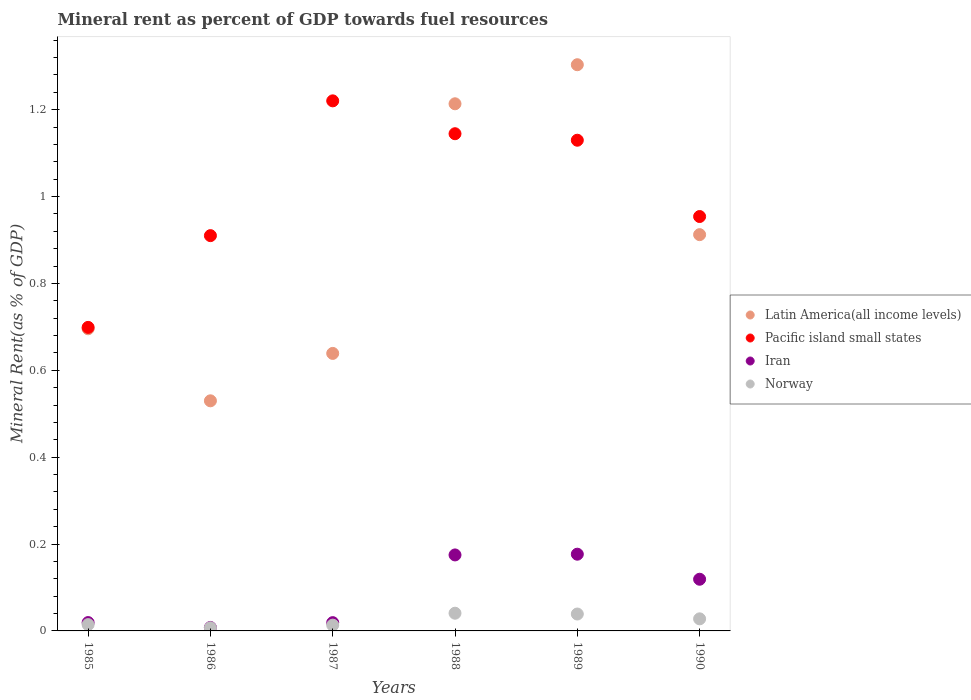How many different coloured dotlines are there?
Offer a very short reply. 4. What is the mineral rent in Latin America(all income levels) in 1988?
Make the answer very short. 1.21. Across all years, what is the maximum mineral rent in Latin America(all income levels)?
Keep it short and to the point. 1.3. Across all years, what is the minimum mineral rent in Norway?
Ensure brevity in your answer.  0.01. In which year was the mineral rent in Pacific island small states maximum?
Give a very brief answer. 1987. What is the total mineral rent in Latin America(all income levels) in the graph?
Your answer should be very brief. 5.29. What is the difference between the mineral rent in Latin America(all income levels) in 1985 and that in 1987?
Your response must be concise. 0.06. What is the difference between the mineral rent in Norway in 1988 and the mineral rent in Iran in 1986?
Your answer should be compact. 0.03. What is the average mineral rent in Iran per year?
Make the answer very short. 0.09. In the year 1989, what is the difference between the mineral rent in Iran and mineral rent in Latin America(all income levels)?
Provide a succinct answer. -1.13. In how many years, is the mineral rent in Latin America(all income levels) greater than 0.56 %?
Make the answer very short. 5. What is the ratio of the mineral rent in Norway in 1987 to that in 1990?
Make the answer very short. 0.48. What is the difference between the highest and the second highest mineral rent in Pacific island small states?
Offer a very short reply. 0.08. What is the difference between the highest and the lowest mineral rent in Norway?
Offer a terse response. 0.03. In how many years, is the mineral rent in Iran greater than the average mineral rent in Iran taken over all years?
Ensure brevity in your answer.  3. Is the sum of the mineral rent in Latin America(all income levels) in 1985 and 1990 greater than the maximum mineral rent in Pacific island small states across all years?
Give a very brief answer. Yes. Is the mineral rent in Pacific island small states strictly less than the mineral rent in Latin America(all income levels) over the years?
Your answer should be very brief. No. How many dotlines are there?
Provide a short and direct response. 4. How many years are there in the graph?
Give a very brief answer. 6. Does the graph contain grids?
Your answer should be very brief. No. How many legend labels are there?
Offer a terse response. 4. How are the legend labels stacked?
Provide a short and direct response. Vertical. What is the title of the graph?
Ensure brevity in your answer.  Mineral rent as percent of GDP towards fuel resources. Does "Algeria" appear as one of the legend labels in the graph?
Your answer should be very brief. No. What is the label or title of the X-axis?
Ensure brevity in your answer.  Years. What is the label or title of the Y-axis?
Offer a very short reply. Mineral Rent(as % of GDP). What is the Mineral Rent(as % of GDP) in Latin America(all income levels) in 1985?
Provide a short and direct response. 0.7. What is the Mineral Rent(as % of GDP) in Pacific island small states in 1985?
Ensure brevity in your answer.  0.7. What is the Mineral Rent(as % of GDP) of Iran in 1985?
Give a very brief answer. 0.02. What is the Mineral Rent(as % of GDP) in Norway in 1985?
Your response must be concise. 0.01. What is the Mineral Rent(as % of GDP) in Latin America(all income levels) in 1986?
Keep it short and to the point. 0.53. What is the Mineral Rent(as % of GDP) of Pacific island small states in 1986?
Keep it short and to the point. 0.91. What is the Mineral Rent(as % of GDP) of Iran in 1986?
Your answer should be very brief. 0.01. What is the Mineral Rent(as % of GDP) in Norway in 1986?
Provide a succinct answer. 0.01. What is the Mineral Rent(as % of GDP) of Latin America(all income levels) in 1987?
Your answer should be compact. 0.64. What is the Mineral Rent(as % of GDP) of Pacific island small states in 1987?
Give a very brief answer. 1.22. What is the Mineral Rent(as % of GDP) in Iran in 1987?
Provide a succinct answer. 0.02. What is the Mineral Rent(as % of GDP) of Norway in 1987?
Your answer should be very brief. 0.01. What is the Mineral Rent(as % of GDP) in Latin America(all income levels) in 1988?
Your answer should be very brief. 1.21. What is the Mineral Rent(as % of GDP) of Pacific island small states in 1988?
Your answer should be very brief. 1.14. What is the Mineral Rent(as % of GDP) in Iran in 1988?
Keep it short and to the point. 0.17. What is the Mineral Rent(as % of GDP) in Norway in 1988?
Your response must be concise. 0.04. What is the Mineral Rent(as % of GDP) in Latin America(all income levels) in 1989?
Provide a succinct answer. 1.3. What is the Mineral Rent(as % of GDP) of Pacific island small states in 1989?
Your answer should be very brief. 1.13. What is the Mineral Rent(as % of GDP) of Iran in 1989?
Your answer should be very brief. 0.18. What is the Mineral Rent(as % of GDP) of Norway in 1989?
Provide a short and direct response. 0.04. What is the Mineral Rent(as % of GDP) of Latin America(all income levels) in 1990?
Keep it short and to the point. 0.91. What is the Mineral Rent(as % of GDP) of Pacific island small states in 1990?
Offer a terse response. 0.95. What is the Mineral Rent(as % of GDP) of Iran in 1990?
Provide a short and direct response. 0.12. What is the Mineral Rent(as % of GDP) of Norway in 1990?
Your response must be concise. 0.03. Across all years, what is the maximum Mineral Rent(as % of GDP) of Latin America(all income levels)?
Provide a succinct answer. 1.3. Across all years, what is the maximum Mineral Rent(as % of GDP) of Pacific island small states?
Provide a short and direct response. 1.22. Across all years, what is the maximum Mineral Rent(as % of GDP) of Iran?
Make the answer very short. 0.18. Across all years, what is the maximum Mineral Rent(as % of GDP) of Norway?
Ensure brevity in your answer.  0.04. Across all years, what is the minimum Mineral Rent(as % of GDP) of Latin America(all income levels)?
Offer a terse response. 0.53. Across all years, what is the minimum Mineral Rent(as % of GDP) of Pacific island small states?
Offer a very short reply. 0.7. Across all years, what is the minimum Mineral Rent(as % of GDP) in Iran?
Provide a succinct answer. 0.01. Across all years, what is the minimum Mineral Rent(as % of GDP) in Norway?
Provide a short and direct response. 0.01. What is the total Mineral Rent(as % of GDP) in Latin America(all income levels) in the graph?
Your answer should be compact. 5.29. What is the total Mineral Rent(as % of GDP) in Pacific island small states in the graph?
Keep it short and to the point. 6.06. What is the total Mineral Rent(as % of GDP) in Iran in the graph?
Offer a terse response. 0.52. What is the total Mineral Rent(as % of GDP) of Norway in the graph?
Offer a terse response. 0.14. What is the difference between the Mineral Rent(as % of GDP) in Latin America(all income levels) in 1985 and that in 1986?
Your answer should be compact. 0.17. What is the difference between the Mineral Rent(as % of GDP) in Pacific island small states in 1985 and that in 1986?
Offer a terse response. -0.21. What is the difference between the Mineral Rent(as % of GDP) of Iran in 1985 and that in 1986?
Make the answer very short. 0.01. What is the difference between the Mineral Rent(as % of GDP) of Norway in 1985 and that in 1986?
Provide a succinct answer. 0.01. What is the difference between the Mineral Rent(as % of GDP) in Latin America(all income levels) in 1985 and that in 1987?
Make the answer very short. 0.06. What is the difference between the Mineral Rent(as % of GDP) in Pacific island small states in 1985 and that in 1987?
Give a very brief answer. -0.52. What is the difference between the Mineral Rent(as % of GDP) of Norway in 1985 and that in 1987?
Make the answer very short. 0. What is the difference between the Mineral Rent(as % of GDP) of Latin America(all income levels) in 1985 and that in 1988?
Offer a very short reply. -0.52. What is the difference between the Mineral Rent(as % of GDP) in Pacific island small states in 1985 and that in 1988?
Your answer should be very brief. -0.45. What is the difference between the Mineral Rent(as % of GDP) in Iran in 1985 and that in 1988?
Provide a succinct answer. -0.16. What is the difference between the Mineral Rent(as % of GDP) in Norway in 1985 and that in 1988?
Ensure brevity in your answer.  -0.03. What is the difference between the Mineral Rent(as % of GDP) of Latin America(all income levels) in 1985 and that in 1989?
Offer a very short reply. -0.61. What is the difference between the Mineral Rent(as % of GDP) in Pacific island small states in 1985 and that in 1989?
Your response must be concise. -0.43. What is the difference between the Mineral Rent(as % of GDP) in Iran in 1985 and that in 1989?
Keep it short and to the point. -0.16. What is the difference between the Mineral Rent(as % of GDP) in Norway in 1985 and that in 1989?
Your answer should be very brief. -0.02. What is the difference between the Mineral Rent(as % of GDP) in Latin America(all income levels) in 1985 and that in 1990?
Give a very brief answer. -0.22. What is the difference between the Mineral Rent(as % of GDP) in Pacific island small states in 1985 and that in 1990?
Give a very brief answer. -0.26. What is the difference between the Mineral Rent(as % of GDP) of Iran in 1985 and that in 1990?
Ensure brevity in your answer.  -0.1. What is the difference between the Mineral Rent(as % of GDP) in Norway in 1985 and that in 1990?
Keep it short and to the point. -0.01. What is the difference between the Mineral Rent(as % of GDP) in Latin America(all income levels) in 1986 and that in 1987?
Give a very brief answer. -0.11. What is the difference between the Mineral Rent(as % of GDP) of Pacific island small states in 1986 and that in 1987?
Give a very brief answer. -0.31. What is the difference between the Mineral Rent(as % of GDP) of Iran in 1986 and that in 1987?
Ensure brevity in your answer.  -0.01. What is the difference between the Mineral Rent(as % of GDP) of Norway in 1986 and that in 1987?
Your answer should be compact. -0.01. What is the difference between the Mineral Rent(as % of GDP) of Latin America(all income levels) in 1986 and that in 1988?
Provide a short and direct response. -0.68. What is the difference between the Mineral Rent(as % of GDP) of Pacific island small states in 1986 and that in 1988?
Offer a very short reply. -0.23. What is the difference between the Mineral Rent(as % of GDP) in Iran in 1986 and that in 1988?
Make the answer very short. -0.17. What is the difference between the Mineral Rent(as % of GDP) in Norway in 1986 and that in 1988?
Keep it short and to the point. -0.03. What is the difference between the Mineral Rent(as % of GDP) in Latin America(all income levels) in 1986 and that in 1989?
Your response must be concise. -0.77. What is the difference between the Mineral Rent(as % of GDP) of Pacific island small states in 1986 and that in 1989?
Keep it short and to the point. -0.22. What is the difference between the Mineral Rent(as % of GDP) in Iran in 1986 and that in 1989?
Ensure brevity in your answer.  -0.17. What is the difference between the Mineral Rent(as % of GDP) of Norway in 1986 and that in 1989?
Keep it short and to the point. -0.03. What is the difference between the Mineral Rent(as % of GDP) in Latin America(all income levels) in 1986 and that in 1990?
Keep it short and to the point. -0.38. What is the difference between the Mineral Rent(as % of GDP) of Pacific island small states in 1986 and that in 1990?
Provide a short and direct response. -0.04. What is the difference between the Mineral Rent(as % of GDP) in Iran in 1986 and that in 1990?
Make the answer very short. -0.11. What is the difference between the Mineral Rent(as % of GDP) in Norway in 1986 and that in 1990?
Your response must be concise. -0.02. What is the difference between the Mineral Rent(as % of GDP) of Latin America(all income levels) in 1987 and that in 1988?
Provide a short and direct response. -0.57. What is the difference between the Mineral Rent(as % of GDP) in Pacific island small states in 1987 and that in 1988?
Offer a terse response. 0.08. What is the difference between the Mineral Rent(as % of GDP) of Iran in 1987 and that in 1988?
Your answer should be compact. -0.16. What is the difference between the Mineral Rent(as % of GDP) in Norway in 1987 and that in 1988?
Ensure brevity in your answer.  -0.03. What is the difference between the Mineral Rent(as % of GDP) of Latin America(all income levels) in 1987 and that in 1989?
Offer a terse response. -0.66. What is the difference between the Mineral Rent(as % of GDP) in Pacific island small states in 1987 and that in 1989?
Provide a succinct answer. 0.09. What is the difference between the Mineral Rent(as % of GDP) in Iran in 1987 and that in 1989?
Provide a short and direct response. -0.16. What is the difference between the Mineral Rent(as % of GDP) of Norway in 1987 and that in 1989?
Your answer should be compact. -0.03. What is the difference between the Mineral Rent(as % of GDP) of Latin America(all income levels) in 1987 and that in 1990?
Keep it short and to the point. -0.27. What is the difference between the Mineral Rent(as % of GDP) of Pacific island small states in 1987 and that in 1990?
Ensure brevity in your answer.  0.27. What is the difference between the Mineral Rent(as % of GDP) of Iran in 1987 and that in 1990?
Ensure brevity in your answer.  -0.1. What is the difference between the Mineral Rent(as % of GDP) of Norway in 1987 and that in 1990?
Keep it short and to the point. -0.01. What is the difference between the Mineral Rent(as % of GDP) in Latin America(all income levels) in 1988 and that in 1989?
Offer a very short reply. -0.09. What is the difference between the Mineral Rent(as % of GDP) of Pacific island small states in 1988 and that in 1989?
Your response must be concise. 0.01. What is the difference between the Mineral Rent(as % of GDP) of Iran in 1988 and that in 1989?
Make the answer very short. -0. What is the difference between the Mineral Rent(as % of GDP) of Norway in 1988 and that in 1989?
Provide a succinct answer. 0. What is the difference between the Mineral Rent(as % of GDP) in Latin America(all income levels) in 1988 and that in 1990?
Ensure brevity in your answer.  0.3. What is the difference between the Mineral Rent(as % of GDP) of Pacific island small states in 1988 and that in 1990?
Make the answer very short. 0.19. What is the difference between the Mineral Rent(as % of GDP) in Iran in 1988 and that in 1990?
Offer a terse response. 0.06. What is the difference between the Mineral Rent(as % of GDP) in Norway in 1988 and that in 1990?
Your answer should be very brief. 0.01. What is the difference between the Mineral Rent(as % of GDP) in Latin America(all income levels) in 1989 and that in 1990?
Keep it short and to the point. 0.39. What is the difference between the Mineral Rent(as % of GDP) of Pacific island small states in 1989 and that in 1990?
Offer a terse response. 0.18. What is the difference between the Mineral Rent(as % of GDP) of Iran in 1989 and that in 1990?
Keep it short and to the point. 0.06. What is the difference between the Mineral Rent(as % of GDP) of Norway in 1989 and that in 1990?
Offer a terse response. 0.01. What is the difference between the Mineral Rent(as % of GDP) of Latin America(all income levels) in 1985 and the Mineral Rent(as % of GDP) of Pacific island small states in 1986?
Make the answer very short. -0.21. What is the difference between the Mineral Rent(as % of GDP) in Latin America(all income levels) in 1985 and the Mineral Rent(as % of GDP) in Iran in 1986?
Your answer should be compact. 0.69. What is the difference between the Mineral Rent(as % of GDP) in Latin America(all income levels) in 1985 and the Mineral Rent(as % of GDP) in Norway in 1986?
Provide a succinct answer. 0.69. What is the difference between the Mineral Rent(as % of GDP) in Pacific island small states in 1985 and the Mineral Rent(as % of GDP) in Iran in 1986?
Your answer should be compact. 0.69. What is the difference between the Mineral Rent(as % of GDP) of Pacific island small states in 1985 and the Mineral Rent(as % of GDP) of Norway in 1986?
Your answer should be compact. 0.69. What is the difference between the Mineral Rent(as % of GDP) of Iran in 1985 and the Mineral Rent(as % of GDP) of Norway in 1986?
Provide a succinct answer. 0.01. What is the difference between the Mineral Rent(as % of GDP) of Latin America(all income levels) in 1985 and the Mineral Rent(as % of GDP) of Pacific island small states in 1987?
Ensure brevity in your answer.  -0.52. What is the difference between the Mineral Rent(as % of GDP) of Latin America(all income levels) in 1985 and the Mineral Rent(as % of GDP) of Iran in 1987?
Give a very brief answer. 0.68. What is the difference between the Mineral Rent(as % of GDP) in Latin America(all income levels) in 1985 and the Mineral Rent(as % of GDP) in Norway in 1987?
Ensure brevity in your answer.  0.68. What is the difference between the Mineral Rent(as % of GDP) in Pacific island small states in 1985 and the Mineral Rent(as % of GDP) in Iran in 1987?
Ensure brevity in your answer.  0.68. What is the difference between the Mineral Rent(as % of GDP) in Pacific island small states in 1985 and the Mineral Rent(as % of GDP) in Norway in 1987?
Provide a succinct answer. 0.69. What is the difference between the Mineral Rent(as % of GDP) in Iran in 1985 and the Mineral Rent(as % of GDP) in Norway in 1987?
Provide a short and direct response. 0.01. What is the difference between the Mineral Rent(as % of GDP) of Latin America(all income levels) in 1985 and the Mineral Rent(as % of GDP) of Pacific island small states in 1988?
Your response must be concise. -0.45. What is the difference between the Mineral Rent(as % of GDP) of Latin America(all income levels) in 1985 and the Mineral Rent(as % of GDP) of Iran in 1988?
Provide a short and direct response. 0.52. What is the difference between the Mineral Rent(as % of GDP) of Latin America(all income levels) in 1985 and the Mineral Rent(as % of GDP) of Norway in 1988?
Make the answer very short. 0.65. What is the difference between the Mineral Rent(as % of GDP) of Pacific island small states in 1985 and the Mineral Rent(as % of GDP) of Iran in 1988?
Provide a succinct answer. 0.52. What is the difference between the Mineral Rent(as % of GDP) in Pacific island small states in 1985 and the Mineral Rent(as % of GDP) in Norway in 1988?
Keep it short and to the point. 0.66. What is the difference between the Mineral Rent(as % of GDP) of Iran in 1985 and the Mineral Rent(as % of GDP) of Norway in 1988?
Offer a very short reply. -0.02. What is the difference between the Mineral Rent(as % of GDP) in Latin America(all income levels) in 1985 and the Mineral Rent(as % of GDP) in Pacific island small states in 1989?
Provide a short and direct response. -0.43. What is the difference between the Mineral Rent(as % of GDP) in Latin America(all income levels) in 1985 and the Mineral Rent(as % of GDP) in Iran in 1989?
Make the answer very short. 0.52. What is the difference between the Mineral Rent(as % of GDP) in Latin America(all income levels) in 1985 and the Mineral Rent(as % of GDP) in Norway in 1989?
Offer a terse response. 0.66. What is the difference between the Mineral Rent(as % of GDP) in Pacific island small states in 1985 and the Mineral Rent(as % of GDP) in Iran in 1989?
Ensure brevity in your answer.  0.52. What is the difference between the Mineral Rent(as % of GDP) of Pacific island small states in 1985 and the Mineral Rent(as % of GDP) of Norway in 1989?
Provide a short and direct response. 0.66. What is the difference between the Mineral Rent(as % of GDP) in Iran in 1985 and the Mineral Rent(as % of GDP) in Norway in 1989?
Make the answer very short. -0.02. What is the difference between the Mineral Rent(as % of GDP) in Latin America(all income levels) in 1985 and the Mineral Rent(as % of GDP) in Pacific island small states in 1990?
Ensure brevity in your answer.  -0.26. What is the difference between the Mineral Rent(as % of GDP) in Latin America(all income levels) in 1985 and the Mineral Rent(as % of GDP) in Iran in 1990?
Offer a terse response. 0.58. What is the difference between the Mineral Rent(as % of GDP) in Latin America(all income levels) in 1985 and the Mineral Rent(as % of GDP) in Norway in 1990?
Your answer should be very brief. 0.67. What is the difference between the Mineral Rent(as % of GDP) in Pacific island small states in 1985 and the Mineral Rent(as % of GDP) in Iran in 1990?
Offer a very short reply. 0.58. What is the difference between the Mineral Rent(as % of GDP) of Pacific island small states in 1985 and the Mineral Rent(as % of GDP) of Norway in 1990?
Offer a very short reply. 0.67. What is the difference between the Mineral Rent(as % of GDP) in Iran in 1985 and the Mineral Rent(as % of GDP) in Norway in 1990?
Your answer should be compact. -0.01. What is the difference between the Mineral Rent(as % of GDP) in Latin America(all income levels) in 1986 and the Mineral Rent(as % of GDP) in Pacific island small states in 1987?
Offer a terse response. -0.69. What is the difference between the Mineral Rent(as % of GDP) in Latin America(all income levels) in 1986 and the Mineral Rent(as % of GDP) in Iran in 1987?
Keep it short and to the point. 0.51. What is the difference between the Mineral Rent(as % of GDP) of Latin America(all income levels) in 1986 and the Mineral Rent(as % of GDP) of Norway in 1987?
Give a very brief answer. 0.52. What is the difference between the Mineral Rent(as % of GDP) of Pacific island small states in 1986 and the Mineral Rent(as % of GDP) of Iran in 1987?
Give a very brief answer. 0.89. What is the difference between the Mineral Rent(as % of GDP) in Pacific island small states in 1986 and the Mineral Rent(as % of GDP) in Norway in 1987?
Your answer should be very brief. 0.9. What is the difference between the Mineral Rent(as % of GDP) of Iran in 1986 and the Mineral Rent(as % of GDP) of Norway in 1987?
Your answer should be very brief. -0.01. What is the difference between the Mineral Rent(as % of GDP) in Latin America(all income levels) in 1986 and the Mineral Rent(as % of GDP) in Pacific island small states in 1988?
Your response must be concise. -0.61. What is the difference between the Mineral Rent(as % of GDP) in Latin America(all income levels) in 1986 and the Mineral Rent(as % of GDP) in Iran in 1988?
Keep it short and to the point. 0.35. What is the difference between the Mineral Rent(as % of GDP) in Latin America(all income levels) in 1986 and the Mineral Rent(as % of GDP) in Norway in 1988?
Your response must be concise. 0.49. What is the difference between the Mineral Rent(as % of GDP) in Pacific island small states in 1986 and the Mineral Rent(as % of GDP) in Iran in 1988?
Your answer should be compact. 0.73. What is the difference between the Mineral Rent(as % of GDP) in Pacific island small states in 1986 and the Mineral Rent(as % of GDP) in Norway in 1988?
Keep it short and to the point. 0.87. What is the difference between the Mineral Rent(as % of GDP) in Iran in 1986 and the Mineral Rent(as % of GDP) in Norway in 1988?
Your answer should be very brief. -0.03. What is the difference between the Mineral Rent(as % of GDP) in Latin America(all income levels) in 1986 and the Mineral Rent(as % of GDP) in Pacific island small states in 1989?
Give a very brief answer. -0.6. What is the difference between the Mineral Rent(as % of GDP) of Latin America(all income levels) in 1986 and the Mineral Rent(as % of GDP) of Iran in 1989?
Offer a very short reply. 0.35. What is the difference between the Mineral Rent(as % of GDP) of Latin America(all income levels) in 1986 and the Mineral Rent(as % of GDP) of Norway in 1989?
Ensure brevity in your answer.  0.49. What is the difference between the Mineral Rent(as % of GDP) in Pacific island small states in 1986 and the Mineral Rent(as % of GDP) in Iran in 1989?
Keep it short and to the point. 0.73. What is the difference between the Mineral Rent(as % of GDP) in Pacific island small states in 1986 and the Mineral Rent(as % of GDP) in Norway in 1989?
Keep it short and to the point. 0.87. What is the difference between the Mineral Rent(as % of GDP) in Iran in 1986 and the Mineral Rent(as % of GDP) in Norway in 1989?
Provide a succinct answer. -0.03. What is the difference between the Mineral Rent(as % of GDP) of Latin America(all income levels) in 1986 and the Mineral Rent(as % of GDP) of Pacific island small states in 1990?
Your answer should be very brief. -0.42. What is the difference between the Mineral Rent(as % of GDP) in Latin America(all income levels) in 1986 and the Mineral Rent(as % of GDP) in Iran in 1990?
Keep it short and to the point. 0.41. What is the difference between the Mineral Rent(as % of GDP) in Latin America(all income levels) in 1986 and the Mineral Rent(as % of GDP) in Norway in 1990?
Make the answer very short. 0.5. What is the difference between the Mineral Rent(as % of GDP) in Pacific island small states in 1986 and the Mineral Rent(as % of GDP) in Iran in 1990?
Give a very brief answer. 0.79. What is the difference between the Mineral Rent(as % of GDP) of Pacific island small states in 1986 and the Mineral Rent(as % of GDP) of Norway in 1990?
Ensure brevity in your answer.  0.88. What is the difference between the Mineral Rent(as % of GDP) of Iran in 1986 and the Mineral Rent(as % of GDP) of Norway in 1990?
Your response must be concise. -0.02. What is the difference between the Mineral Rent(as % of GDP) in Latin America(all income levels) in 1987 and the Mineral Rent(as % of GDP) in Pacific island small states in 1988?
Your response must be concise. -0.51. What is the difference between the Mineral Rent(as % of GDP) in Latin America(all income levels) in 1987 and the Mineral Rent(as % of GDP) in Iran in 1988?
Your answer should be compact. 0.46. What is the difference between the Mineral Rent(as % of GDP) in Latin America(all income levels) in 1987 and the Mineral Rent(as % of GDP) in Norway in 1988?
Provide a succinct answer. 0.6. What is the difference between the Mineral Rent(as % of GDP) in Pacific island small states in 1987 and the Mineral Rent(as % of GDP) in Iran in 1988?
Your answer should be very brief. 1.05. What is the difference between the Mineral Rent(as % of GDP) in Pacific island small states in 1987 and the Mineral Rent(as % of GDP) in Norway in 1988?
Provide a succinct answer. 1.18. What is the difference between the Mineral Rent(as % of GDP) of Iran in 1987 and the Mineral Rent(as % of GDP) of Norway in 1988?
Ensure brevity in your answer.  -0.02. What is the difference between the Mineral Rent(as % of GDP) in Latin America(all income levels) in 1987 and the Mineral Rent(as % of GDP) in Pacific island small states in 1989?
Keep it short and to the point. -0.49. What is the difference between the Mineral Rent(as % of GDP) of Latin America(all income levels) in 1987 and the Mineral Rent(as % of GDP) of Iran in 1989?
Your answer should be compact. 0.46. What is the difference between the Mineral Rent(as % of GDP) in Latin America(all income levels) in 1987 and the Mineral Rent(as % of GDP) in Norway in 1989?
Provide a short and direct response. 0.6. What is the difference between the Mineral Rent(as % of GDP) in Pacific island small states in 1987 and the Mineral Rent(as % of GDP) in Iran in 1989?
Give a very brief answer. 1.04. What is the difference between the Mineral Rent(as % of GDP) in Pacific island small states in 1987 and the Mineral Rent(as % of GDP) in Norway in 1989?
Ensure brevity in your answer.  1.18. What is the difference between the Mineral Rent(as % of GDP) of Iran in 1987 and the Mineral Rent(as % of GDP) of Norway in 1989?
Offer a terse response. -0.02. What is the difference between the Mineral Rent(as % of GDP) in Latin America(all income levels) in 1987 and the Mineral Rent(as % of GDP) in Pacific island small states in 1990?
Offer a very short reply. -0.32. What is the difference between the Mineral Rent(as % of GDP) in Latin America(all income levels) in 1987 and the Mineral Rent(as % of GDP) in Iran in 1990?
Provide a succinct answer. 0.52. What is the difference between the Mineral Rent(as % of GDP) of Latin America(all income levels) in 1987 and the Mineral Rent(as % of GDP) of Norway in 1990?
Your response must be concise. 0.61. What is the difference between the Mineral Rent(as % of GDP) in Pacific island small states in 1987 and the Mineral Rent(as % of GDP) in Iran in 1990?
Give a very brief answer. 1.1. What is the difference between the Mineral Rent(as % of GDP) of Pacific island small states in 1987 and the Mineral Rent(as % of GDP) of Norway in 1990?
Give a very brief answer. 1.19. What is the difference between the Mineral Rent(as % of GDP) of Iran in 1987 and the Mineral Rent(as % of GDP) of Norway in 1990?
Give a very brief answer. -0.01. What is the difference between the Mineral Rent(as % of GDP) in Latin America(all income levels) in 1988 and the Mineral Rent(as % of GDP) in Pacific island small states in 1989?
Give a very brief answer. 0.08. What is the difference between the Mineral Rent(as % of GDP) in Latin America(all income levels) in 1988 and the Mineral Rent(as % of GDP) in Iran in 1989?
Offer a terse response. 1.04. What is the difference between the Mineral Rent(as % of GDP) of Latin America(all income levels) in 1988 and the Mineral Rent(as % of GDP) of Norway in 1989?
Ensure brevity in your answer.  1.17. What is the difference between the Mineral Rent(as % of GDP) in Pacific island small states in 1988 and the Mineral Rent(as % of GDP) in Norway in 1989?
Provide a short and direct response. 1.11. What is the difference between the Mineral Rent(as % of GDP) of Iran in 1988 and the Mineral Rent(as % of GDP) of Norway in 1989?
Offer a very short reply. 0.14. What is the difference between the Mineral Rent(as % of GDP) in Latin America(all income levels) in 1988 and the Mineral Rent(as % of GDP) in Pacific island small states in 1990?
Keep it short and to the point. 0.26. What is the difference between the Mineral Rent(as % of GDP) in Latin America(all income levels) in 1988 and the Mineral Rent(as % of GDP) in Iran in 1990?
Provide a succinct answer. 1.09. What is the difference between the Mineral Rent(as % of GDP) in Latin America(all income levels) in 1988 and the Mineral Rent(as % of GDP) in Norway in 1990?
Make the answer very short. 1.19. What is the difference between the Mineral Rent(as % of GDP) in Pacific island small states in 1988 and the Mineral Rent(as % of GDP) in Iran in 1990?
Your response must be concise. 1.03. What is the difference between the Mineral Rent(as % of GDP) in Pacific island small states in 1988 and the Mineral Rent(as % of GDP) in Norway in 1990?
Your answer should be very brief. 1.12. What is the difference between the Mineral Rent(as % of GDP) of Iran in 1988 and the Mineral Rent(as % of GDP) of Norway in 1990?
Provide a succinct answer. 0.15. What is the difference between the Mineral Rent(as % of GDP) of Latin America(all income levels) in 1989 and the Mineral Rent(as % of GDP) of Pacific island small states in 1990?
Give a very brief answer. 0.35. What is the difference between the Mineral Rent(as % of GDP) in Latin America(all income levels) in 1989 and the Mineral Rent(as % of GDP) in Iran in 1990?
Give a very brief answer. 1.18. What is the difference between the Mineral Rent(as % of GDP) of Latin America(all income levels) in 1989 and the Mineral Rent(as % of GDP) of Norway in 1990?
Make the answer very short. 1.28. What is the difference between the Mineral Rent(as % of GDP) in Pacific island small states in 1989 and the Mineral Rent(as % of GDP) in Iran in 1990?
Ensure brevity in your answer.  1.01. What is the difference between the Mineral Rent(as % of GDP) in Pacific island small states in 1989 and the Mineral Rent(as % of GDP) in Norway in 1990?
Provide a short and direct response. 1.1. What is the difference between the Mineral Rent(as % of GDP) in Iran in 1989 and the Mineral Rent(as % of GDP) in Norway in 1990?
Your answer should be compact. 0.15. What is the average Mineral Rent(as % of GDP) in Latin America(all income levels) per year?
Give a very brief answer. 0.88. What is the average Mineral Rent(as % of GDP) of Pacific island small states per year?
Your answer should be very brief. 1.01. What is the average Mineral Rent(as % of GDP) of Iran per year?
Make the answer very short. 0.09. What is the average Mineral Rent(as % of GDP) of Norway per year?
Your answer should be very brief. 0.02. In the year 1985, what is the difference between the Mineral Rent(as % of GDP) in Latin America(all income levels) and Mineral Rent(as % of GDP) in Pacific island small states?
Offer a very short reply. -0. In the year 1985, what is the difference between the Mineral Rent(as % of GDP) of Latin America(all income levels) and Mineral Rent(as % of GDP) of Iran?
Your answer should be compact. 0.68. In the year 1985, what is the difference between the Mineral Rent(as % of GDP) of Latin America(all income levels) and Mineral Rent(as % of GDP) of Norway?
Provide a short and direct response. 0.68. In the year 1985, what is the difference between the Mineral Rent(as % of GDP) in Pacific island small states and Mineral Rent(as % of GDP) in Iran?
Offer a terse response. 0.68. In the year 1985, what is the difference between the Mineral Rent(as % of GDP) of Pacific island small states and Mineral Rent(as % of GDP) of Norway?
Your response must be concise. 0.68. In the year 1985, what is the difference between the Mineral Rent(as % of GDP) of Iran and Mineral Rent(as % of GDP) of Norway?
Provide a succinct answer. 0. In the year 1986, what is the difference between the Mineral Rent(as % of GDP) in Latin America(all income levels) and Mineral Rent(as % of GDP) in Pacific island small states?
Keep it short and to the point. -0.38. In the year 1986, what is the difference between the Mineral Rent(as % of GDP) in Latin America(all income levels) and Mineral Rent(as % of GDP) in Iran?
Offer a very short reply. 0.52. In the year 1986, what is the difference between the Mineral Rent(as % of GDP) in Latin America(all income levels) and Mineral Rent(as % of GDP) in Norway?
Your answer should be very brief. 0.52. In the year 1986, what is the difference between the Mineral Rent(as % of GDP) of Pacific island small states and Mineral Rent(as % of GDP) of Iran?
Ensure brevity in your answer.  0.9. In the year 1986, what is the difference between the Mineral Rent(as % of GDP) in Pacific island small states and Mineral Rent(as % of GDP) in Norway?
Provide a succinct answer. 0.9. In the year 1986, what is the difference between the Mineral Rent(as % of GDP) in Iran and Mineral Rent(as % of GDP) in Norway?
Provide a short and direct response. 0. In the year 1987, what is the difference between the Mineral Rent(as % of GDP) in Latin America(all income levels) and Mineral Rent(as % of GDP) in Pacific island small states?
Make the answer very short. -0.58. In the year 1987, what is the difference between the Mineral Rent(as % of GDP) in Latin America(all income levels) and Mineral Rent(as % of GDP) in Iran?
Your answer should be very brief. 0.62. In the year 1987, what is the difference between the Mineral Rent(as % of GDP) of Latin America(all income levels) and Mineral Rent(as % of GDP) of Norway?
Keep it short and to the point. 0.63. In the year 1987, what is the difference between the Mineral Rent(as % of GDP) in Pacific island small states and Mineral Rent(as % of GDP) in Iran?
Your answer should be compact. 1.2. In the year 1987, what is the difference between the Mineral Rent(as % of GDP) of Pacific island small states and Mineral Rent(as % of GDP) of Norway?
Your response must be concise. 1.21. In the year 1987, what is the difference between the Mineral Rent(as % of GDP) in Iran and Mineral Rent(as % of GDP) in Norway?
Provide a short and direct response. 0.01. In the year 1988, what is the difference between the Mineral Rent(as % of GDP) of Latin America(all income levels) and Mineral Rent(as % of GDP) of Pacific island small states?
Provide a short and direct response. 0.07. In the year 1988, what is the difference between the Mineral Rent(as % of GDP) in Latin America(all income levels) and Mineral Rent(as % of GDP) in Iran?
Ensure brevity in your answer.  1.04. In the year 1988, what is the difference between the Mineral Rent(as % of GDP) of Latin America(all income levels) and Mineral Rent(as % of GDP) of Norway?
Give a very brief answer. 1.17. In the year 1988, what is the difference between the Mineral Rent(as % of GDP) in Pacific island small states and Mineral Rent(as % of GDP) in Iran?
Your answer should be compact. 0.97. In the year 1988, what is the difference between the Mineral Rent(as % of GDP) in Pacific island small states and Mineral Rent(as % of GDP) in Norway?
Your response must be concise. 1.1. In the year 1988, what is the difference between the Mineral Rent(as % of GDP) in Iran and Mineral Rent(as % of GDP) in Norway?
Offer a very short reply. 0.13. In the year 1989, what is the difference between the Mineral Rent(as % of GDP) in Latin America(all income levels) and Mineral Rent(as % of GDP) in Pacific island small states?
Provide a short and direct response. 0.17. In the year 1989, what is the difference between the Mineral Rent(as % of GDP) of Latin America(all income levels) and Mineral Rent(as % of GDP) of Iran?
Make the answer very short. 1.13. In the year 1989, what is the difference between the Mineral Rent(as % of GDP) in Latin America(all income levels) and Mineral Rent(as % of GDP) in Norway?
Make the answer very short. 1.26. In the year 1989, what is the difference between the Mineral Rent(as % of GDP) in Pacific island small states and Mineral Rent(as % of GDP) in Iran?
Make the answer very short. 0.95. In the year 1989, what is the difference between the Mineral Rent(as % of GDP) in Pacific island small states and Mineral Rent(as % of GDP) in Norway?
Your answer should be compact. 1.09. In the year 1989, what is the difference between the Mineral Rent(as % of GDP) in Iran and Mineral Rent(as % of GDP) in Norway?
Your answer should be compact. 0.14. In the year 1990, what is the difference between the Mineral Rent(as % of GDP) in Latin America(all income levels) and Mineral Rent(as % of GDP) in Pacific island small states?
Make the answer very short. -0.04. In the year 1990, what is the difference between the Mineral Rent(as % of GDP) of Latin America(all income levels) and Mineral Rent(as % of GDP) of Iran?
Provide a short and direct response. 0.79. In the year 1990, what is the difference between the Mineral Rent(as % of GDP) in Latin America(all income levels) and Mineral Rent(as % of GDP) in Norway?
Keep it short and to the point. 0.88. In the year 1990, what is the difference between the Mineral Rent(as % of GDP) in Pacific island small states and Mineral Rent(as % of GDP) in Iran?
Your answer should be very brief. 0.83. In the year 1990, what is the difference between the Mineral Rent(as % of GDP) in Pacific island small states and Mineral Rent(as % of GDP) in Norway?
Your answer should be compact. 0.93. In the year 1990, what is the difference between the Mineral Rent(as % of GDP) of Iran and Mineral Rent(as % of GDP) of Norway?
Keep it short and to the point. 0.09. What is the ratio of the Mineral Rent(as % of GDP) of Latin America(all income levels) in 1985 to that in 1986?
Keep it short and to the point. 1.31. What is the ratio of the Mineral Rent(as % of GDP) of Pacific island small states in 1985 to that in 1986?
Your answer should be compact. 0.77. What is the ratio of the Mineral Rent(as % of GDP) in Iran in 1985 to that in 1986?
Offer a terse response. 2.4. What is the ratio of the Mineral Rent(as % of GDP) of Norway in 1985 to that in 1986?
Offer a terse response. 2.01. What is the ratio of the Mineral Rent(as % of GDP) in Latin America(all income levels) in 1985 to that in 1987?
Provide a succinct answer. 1.09. What is the ratio of the Mineral Rent(as % of GDP) in Pacific island small states in 1985 to that in 1987?
Make the answer very short. 0.57. What is the ratio of the Mineral Rent(as % of GDP) in Iran in 1985 to that in 1987?
Your answer should be very brief. 1.01. What is the ratio of the Mineral Rent(as % of GDP) in Norway in 1985 to that in 1987?
Your answer should be compact. 1.09. What is the ratio of the Mineral Rent(as % of GDP) in Latin America(all income levels) in 1985 to that in 1988?
Offer a terse response. 0.57. What is the ratio of the Mineral Rent(as % of GDP) in Pacific island small states in 1985 to that in 1988?
Keep it short and to the point. 0.61. What is the ratio of the Mineral Rent(as % of GDP) of Iran in 1985 to that in 1988?
Provide a short and direct response. 0.11. What is the ratio of the Mineral Rent(as % of GDP) of Norway in 1985 to that in 1988?
Your answer should be compact. 0.36. What is the ratio of the Mineral Rent(as % of GDP) in Latin America(all income levels) in 1985 to that in 1989?
Keep it short and to the point. 0.53. What is the ratio of the Mineral Rent(as % of GDP) in Pacific island small states in 1985 to that in 1989?
Provide a succinct answer. 0.62. What is the ratio of the Mineral Rent(as % of GDP) in Iran in 1985 to that in 1989?
Keep it short and to the point. 0.11. What is the ratio of the Mineral Rent(as % of GDP) in Norway in 1985 to that in 1989?
Keep it short and to the point. 0.37. What is the ratio of the Mineral Rent(as % of GDP) of Latin America(all income levels) in 1985 to that in 1990?
Give a very brief answer. 0.76. What is the ratio of the Mineral Rent(as % of GDP) in Pacific island small states in 1985 to that in 1990?
Offer a very short reply. 0.73. What is the ratio of the Mineral Rent(as % of GDP) of Iran in 1985 to that in 1990?
Give a very brief answer. 0.16. What is the ratio of the Mineral Rent(as % of GDP) in Norway in 1985 to that in 1990?
Offer a terse response. 0.52. What is the ratio of the Mineral Rent(as % of GDP) of Latin America(all income levels) in 1986 to that in 1987?
Make the answer very short. 0.83. What is the ratio of the Mineral Rent(as % of GDP) in Pacific island small states in 1986 to that in 1987?
Your response must be concise. 0.75. What is the ratio of the Mineral Rent(as % of GDP) of Iran in 1986 to that in 1987?
Keep it short and to the point. 0.42. What is the ratio of the Mineral Rent(as % of GDP) of Norway in 1986 to that in 1987?
Make the answer very short. 0.54. What is the ratio of the Mineral Rent(as % of GDP) of Latin America(all income levels) in 1986 to that in 1988?
Make the answer very short. 0.44. What is the ratio of the Mineral Rent(as % of GDP) in Pacific island small states in 1986 to that in 1988?
Provide a succinct answer. 0.8. What is the ratio of the Mineral Rent(as % of GDP) of Iran in 1986 to that in 1988?
Provide a short and direct response. 0.05. What is the ratio of the Mineral Rent(as % of GDP) of Norway in 1986 to that in 1988?
Make the answer very short. 0.18. What is the ratio of the Mineral Rent(as % of GDP) of Latin America(all income levels) in 1986 to that in 1989?
Keep it short and to the point. 0.41. What is the ratio of the Mineral Rent(as % of GDP) of Pacific island small states in 1986 to that in 1989?
Offer a terse response. 0.81. What is the ratio of the Mineral Rent(as % of GDP) in Iran in 1986 to that in 1989?
Make the answer very short. 0.05. What is the ratio of the Mineral Rent(as % of GDP) in Norway in 1986 to that in 1989?
Make the answer very short. 0.19. What is the ratio of the Mineral Rent(as % of GDP) of Latin America(all income levels) in 1986 to that in 1990?
Offer a terse response. 0.58. What is the ratio of the Mineral Rent(as % of GDP) in Pacific island small states in 1986 to that in 1990?
Make the answer very short. 0.95. What is the ratio of the Mineral Rent(as % of GDP) of Iran in 1986 to that in 1990?
Make the answer very short. 0.07. What is the ratio of the Mineral Rent(as % of GDP) of Norway in 1986 to that in 1990?
Provide a short and direct response. 0.26. What is the ratio of the Mineral Rent(as % of GDP) of Latin America(all income levels) in 1987 to that in 1988?
Your answer should be very brief. 0.53. What is the ratio of the Mineral Rent(as % of GDP) in Pacific island small states in 1987 to that in 1988?
Keep it short and to the point. 1.07. What is the ratio of the Mineral Rent(as % of GDP) in Iran in 1987 to that in 1988?
Offer a terse response. 0.11. What is the ratio of the Mineral Rent(as % of GDP) in Norway in 1987 to that in 1988?
Provide a short and direct response. 0.33. What is the ratio of the Mineral Rent(as % of GDP) in Latin America(all income levels) in 1987 to that in 1989?
Keep it short and to the point. 0.49. What is the ratio of the Mineral Rent(as % of GDP) of Pacific island small states in 1987 to that in 1989?
Keep it short and to the point. 1.08. What is the ratio of the Mineral Rent(as % of GDP) of Iran in 1987 to that in 1989?
Make the answer very short. 0.11. What is the ratio of the Mineral Rent(as % of GDP) of Norway in 1987 to that in 1989?
Your answer should be very brief. 0.34. What is the ratio of the Mineral Rent(as % of GDP) of Latin America(all income levels) in 1987 to that in 1990?
Offer a terse response. 0.7. What is the ratio of the Mineral Rent(as % of GDP) of Pacific island small states in 1987 to that in 1990?
Keep it short and to the point. 1.28. What is the ratio of the Mineral Rent(as % of GDP) in Iran in 1987 to that in 1990?
Your response must be concise. 0.16. What is the ratio of the Mineral Rent(as % of GDP) in Norway in 1987 to that in 1990?
Your response must be concise. 0.48. What is the ratio of the Mineral Rent(as % of GDP) of Latin America(all income levels) in 1988 to that in 1989?
Offer a very short reply. 0.93. What is the ratio of the Mineral Rent(as % of GDP) in Pacific island small states in 1988 to that in 1989?
Provide a short and direct response. 1.01. What is the ratio of the Mineral Rent(as % of GDP) in Norway in 1988 to that in 1989?
Keep it short and to the point. 1.05. What is the ratio of the Mineral Rent(as % of GDP) of Latin America(all income levels) in 1988 to that in 1990?
Make the answer very short. 1.33. What is the ratio of the Mineral Rent(as % of GDP) in Pacific island small states in 1988 to that in 1990?
Offer a terse response. 1.2. What is the ratio of the Mineral Rent(as % of GDP) of Iran in 1988 to that in 1990?
Make the answer very short. 1.47. What is the ratio of the Mineral Rent(as % of GDP) of Norway in 1988 to that in 1990?
Your response must be concise. 1.47. What is the ratio of the Mineral Rent(as % of GDP) in Latin America(all income levels) in 1989 to that in 1990?
Make the answer very short. 1.43. What is the ratio of the Mineral Rent(as % of GDP) in Pacific island small states in 1989 to that in 1990?
Ensure brevity in your answer.  1.18. What is the ratio of the Mineral Rent(as % of GDP) of Iran in 1989 to that in 1990?
Your response must be concise. 1.48. What is the ratio of the Mineral Rent(as % of GDP) in Norway in 1989 to that in 1990?
Keep it short and to the point. 1.4. What is the difference between the highest and the second highest Mineral Rent(as % of GDP) in Latin America(all income levels)?
Your response must be concise. 0.09. What is the difference between the highest and the second highest Mineral Rent(as % of GDP) of Pacific island small states?
Your answer should be very brief. 0.08. What is the difference between the highest and the second highest Mineral Rent(as % of GDP) in Iran?
Provide a succinct answer. 0. What is the difference between the highest and the second highest Mineral Rent(as % of GDP) of Norway?
Make the answer very short. 0. What is the difference between the highest and the lowest Mineral Rent(as % of GDP) in Latin America(all income levels)?
Keep it short and to the point. 0.77. What is the difference between the highest and the lowest Mineral Rent(as % of GDP) of Pacific island small states?
Keep it short and to the point. 0.52. What is the difference between the highest and the lowest Mineral Rent(as % of GDP) in Iran?
Your answer should be compact. 0.17. What is the difference between the highest and the lowest Mineral Rent(as % of GDP) of Norway?
Give a very brief answer. 0.03. 